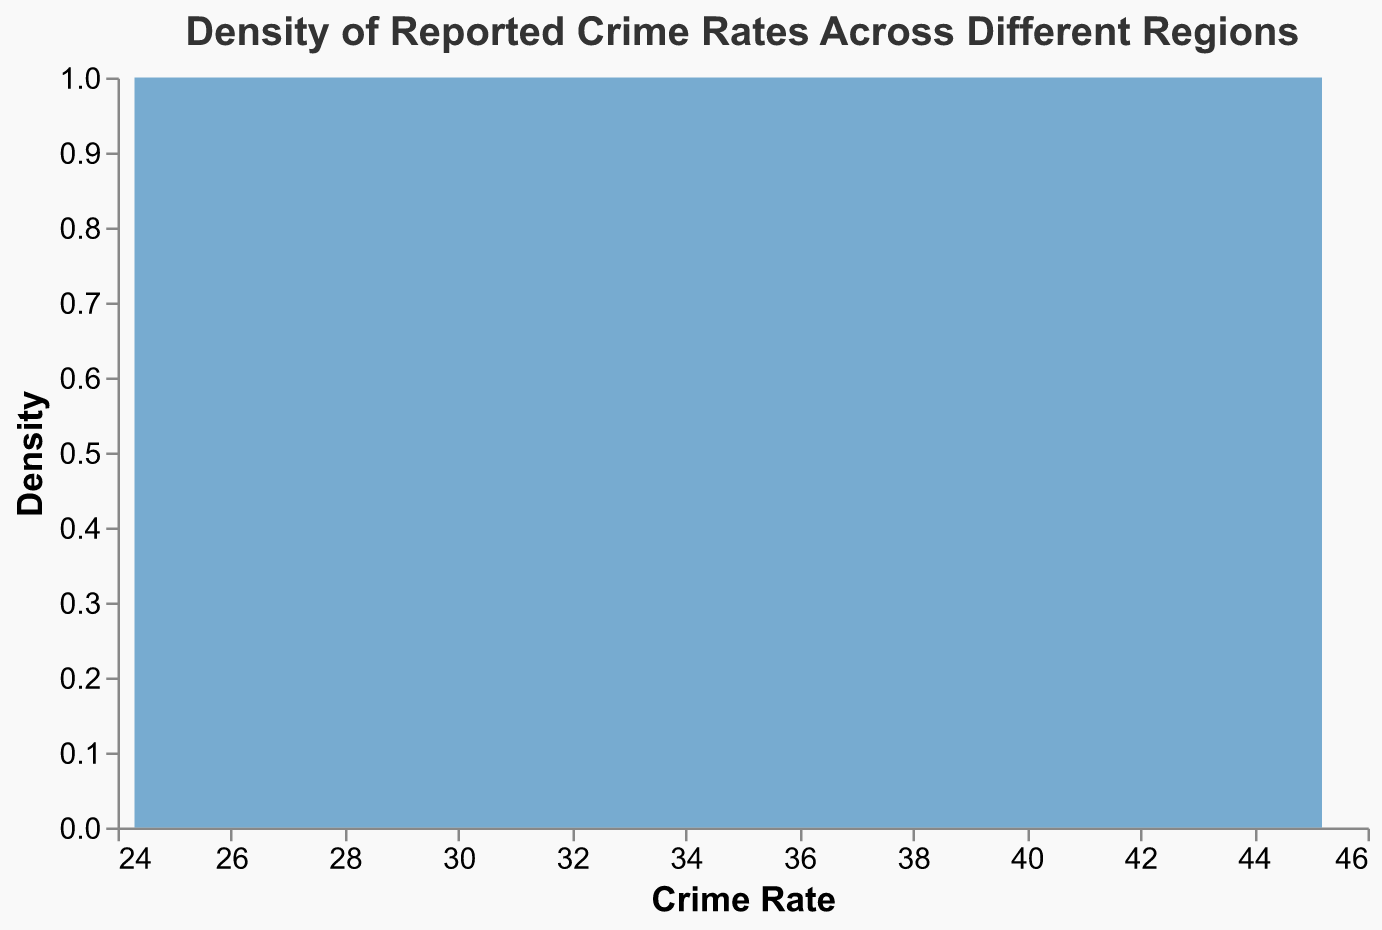What is the title of the figure? The title of the figure is typically displayed at the top and provides context for the data shown. In this case, the title reads "Density of Reported Crime Rates Across Different Regions."
Answer: Density of Reported Crime Rates Across Different Regions What does the x-axis represent? The x-axis represents the variable being measured, which in this case is "Crime Rate." This is indicated by the label provided on the axis.
Answer: Crime Rate What does the y-axis represent? The y-axis represents the density of crime rates reported across different regions. This includes the count or frequency of crime rates falling within specific ranges.
Answer: Density Which state has the highest reported crime rate, according to the data? To find the state with the highest crime rate, look for the highest point on the density plot or examine the highest data point in the data provided, which is California with a crime rate of 45.2.
Answer: California What can you infer about the general trend of crime rates across the different regions? The density plot's overall shape can suggest whether the crime rates are distributed normally, skewed, or have multiple peaks. Typically, the density plot would show if most regions fall within a specific crime rate range.
Answer: Various crime rates with possible clustering What is the range of crime rates reported in the figure? By looking at the minimum and maximum values on the x-axis, you can determine the range of reported crime rates, which spans from around 24.3 (Massachusetts) to 45.2 (California).
Answer: 24.3 to 45.2 Are there more regions with crime rates above or below 35? Referring to the density plot, if there is more area under the curve to the left of the value 35, more regions have crime rates below 35; otherwise, more regions have crime rates above 35.
Answer: To the left of 35 How does the crime rate in Florida compare to the median crime rate of the regions? Calculate the median by sorting the crime rates and finding the middle value. Compare Florida's crime rate of 40.6 to this median. Given the sorted data, the median is approximately 33.5. Florida has a higher crime rate than the median.
Answer: Higher Estimate the mean crime rate across the regions. Sum all the reported crime rates and divide by the number of regions (20). That would be (37.8 + 45.2 + 33.5 + 40.6 + 31.7 + 28.9 + 27.4 + 39.1 + 35.0 + 30.8 + 34.5 + 37.1 + 24.3 + 29.8 + 41.0 + 38.4 + 33.2 + 27.7 + 25.0 + 26.2) = 667.2; 667.2 / 20 = 33.36.
Answer: 33.36 How does the frequency of crime rates around 30 compare to those around 40? Examine the density plot to observe the heights of the curves at both the 30 and 40 crime rate marks. The taller the curve, the higher the frequency for that range. Generally, if the area around 30 is higher, it indicates a higher frequency.
Answer: Higher for around 30 